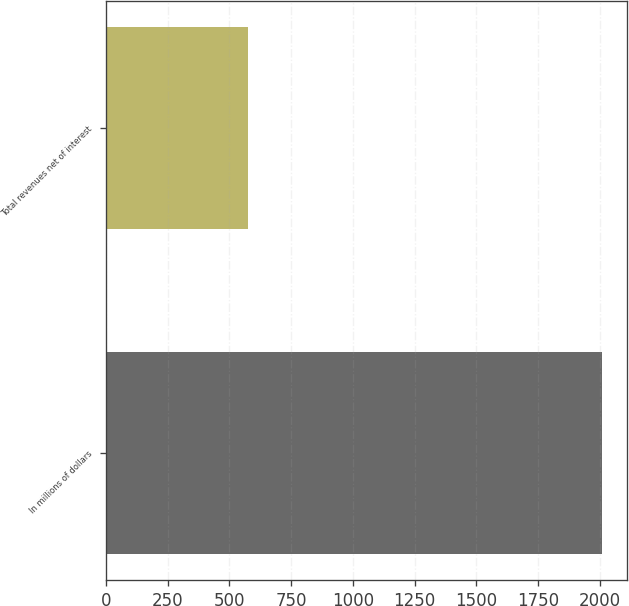<chart> <loc_0><loc_0><loc_500><loc_500><bar_chart><fcel>In millions of dollars<fcel>Total revenues net of interest<nl><fcel>2010<fcel>577<nl></chart> 